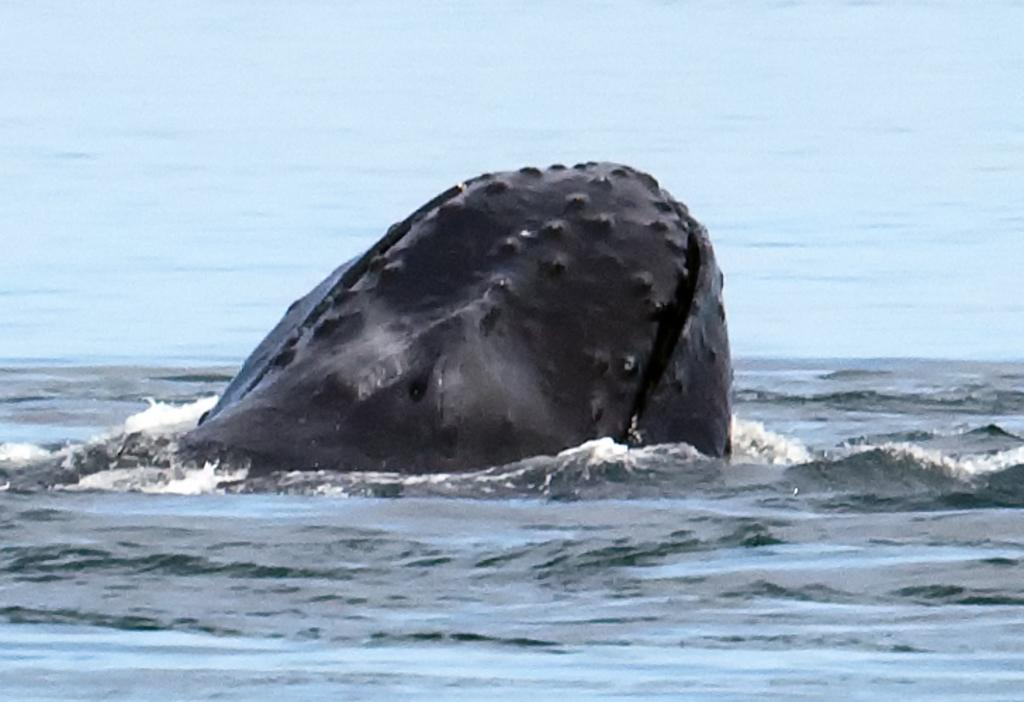What is the main subject of the image? There is an animal in the water in the image. Can you describe the animal in the water? Unfortunately, the facts provided do not give any details about the animal's appearance or type. What is the setting of the image? The image features an animal in the water, which suggests a natural environment such as a lake, river, or ocean. What type of reward does the cub receive after completing the task in the image? There is no mention of a cub or any task being completed in the image. The image only features an animal in the water. 